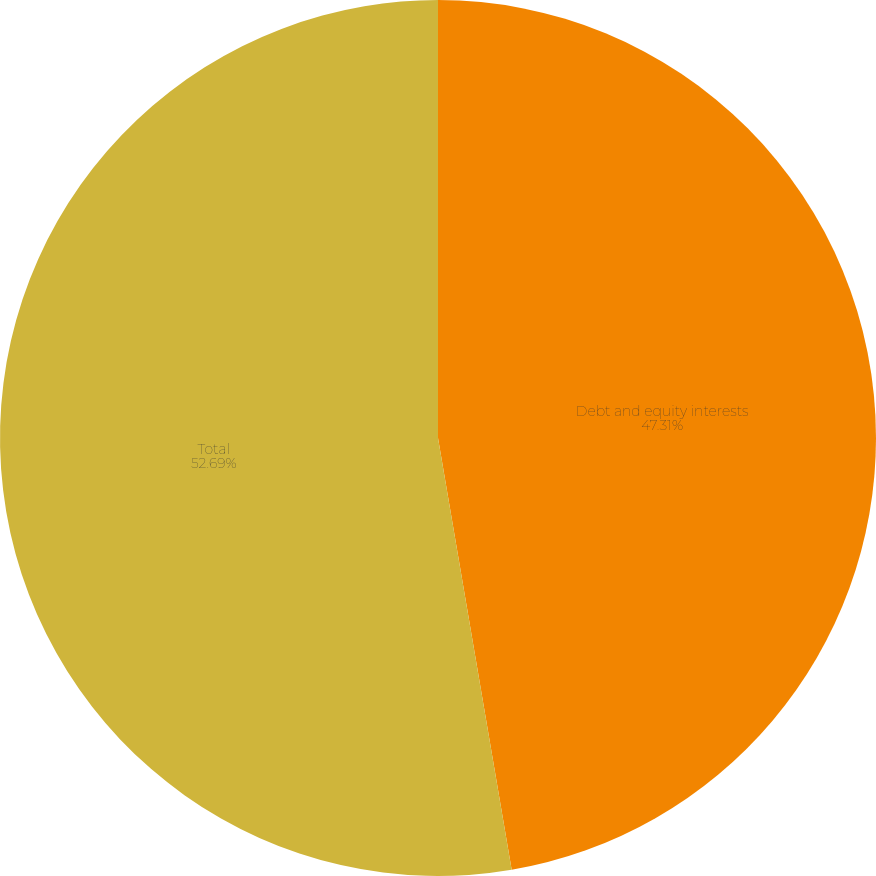Convert chart. <chart><loc_0><loc_0><loc_500><loc_500><pie_chart><fcel>Debt and equity interests<fcel>Total<nl><fcel>47.31%<fcel>52.69%<nl></chart> 